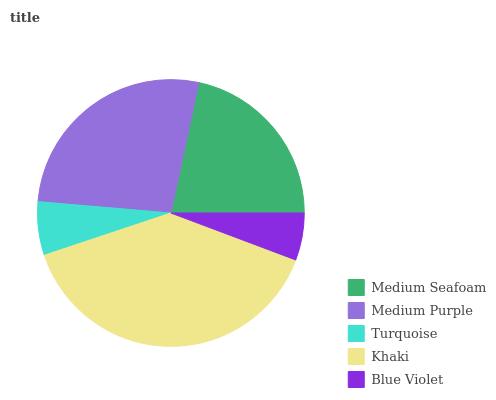Is Blue Violet the minimum?
Answer yes or no. Yes. Is Khaki the maximum?
Answer yes or no. Yes. Is Medium Purple the minimum?
Answer yes or no. No. Is Medium Purple the maximum?
Answer yes or no. No. Is Medium Purple greater than Medium Seafoam?
Answer yes or no. Yes. Is Medium Seafoam less than Medium Purple?
Answer yes or no. Yes. Is Medium Seafoam greater than Medium Purple?
Answer yes or no. No. Is Medium Purple less than Medium Seafoam?
Answer yes or no. No. Is Medium Seafoam the high median?
Answer yes or no. Yes. Is Medium Seafoam the low median?
Answer yes or no. Yes. Is Turquoise the high median?
Answer yes or no. No. Is Blue Violet the low median?
Answer yes or no. No. 